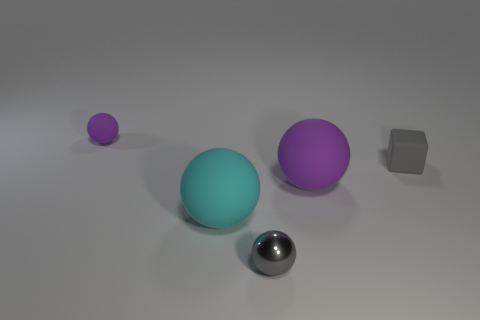There is a thing that is the same color as the small matte ball; what is its size?
Offer a terse response. Large. How many metallic things are either big objects or tiny cubes?
Keep it short and to the point. 0. Are there any other things that are the same material as the tiny gray ball?
Your answer should be compact. No. What size is the purple sphere on the left side of the small gray object that is left of the purple rubber ball that is right of the tiny matte sphere?
Offer a very short reply. Small. What size is the thing that is to the left of the large purple rubber sphere and right of the cyan ball?
Your answer should be very brief. Small. There is a thing on the left side of the cyan ball; is it the same color as the big object that is behind the cyan matte ball?
Offer a terse response. Yes. There is a big purple matte sphere; what number of large matte balls are in front of it?
Your response must be concise. 1. There is a small ball that is to the right of the tiny thing that is behind the small gray block; are there any gray shiny balls on the left side of it?
Keep it short and to the point. No. What number of shiny balls have the same size as the rubber block?
Ensure brevity in your answer.  1. What is the material of the cyan sphere on the right side of the thing behind the small cube?
Make the answer very short. Rubber. 